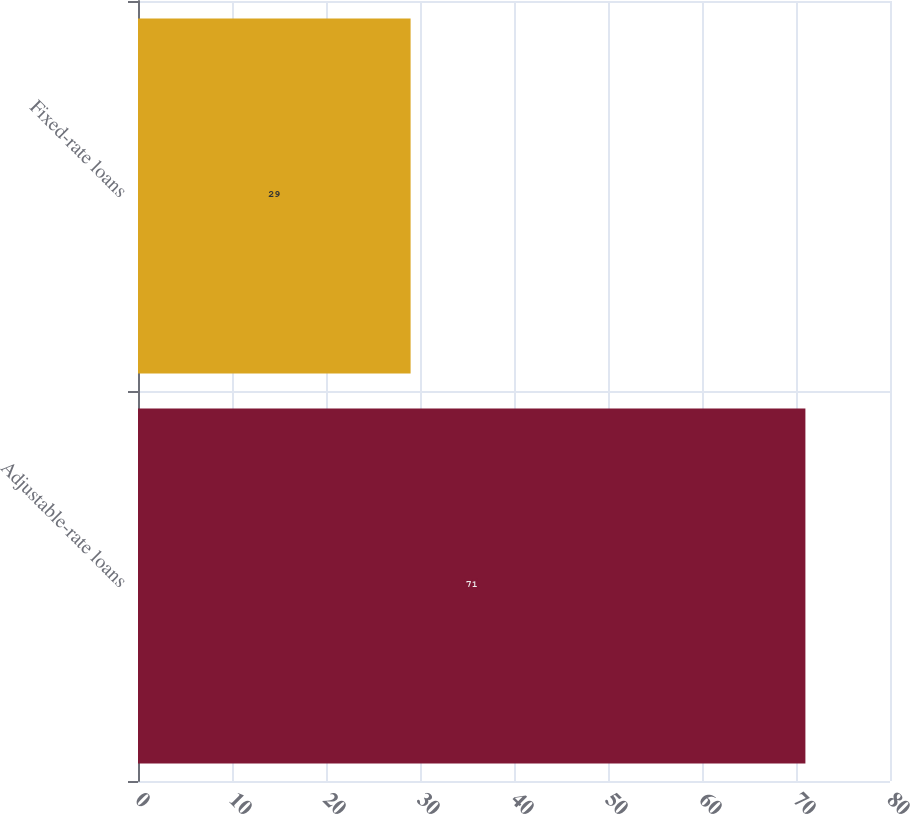<chart> <loc_0><loc_0><loc_500><loc_500><bar_chart><fcel>Adjustable-rate loans<fcel>Fixed-rate loans<nl><fcel>71<fcel>29<nl></chart> 